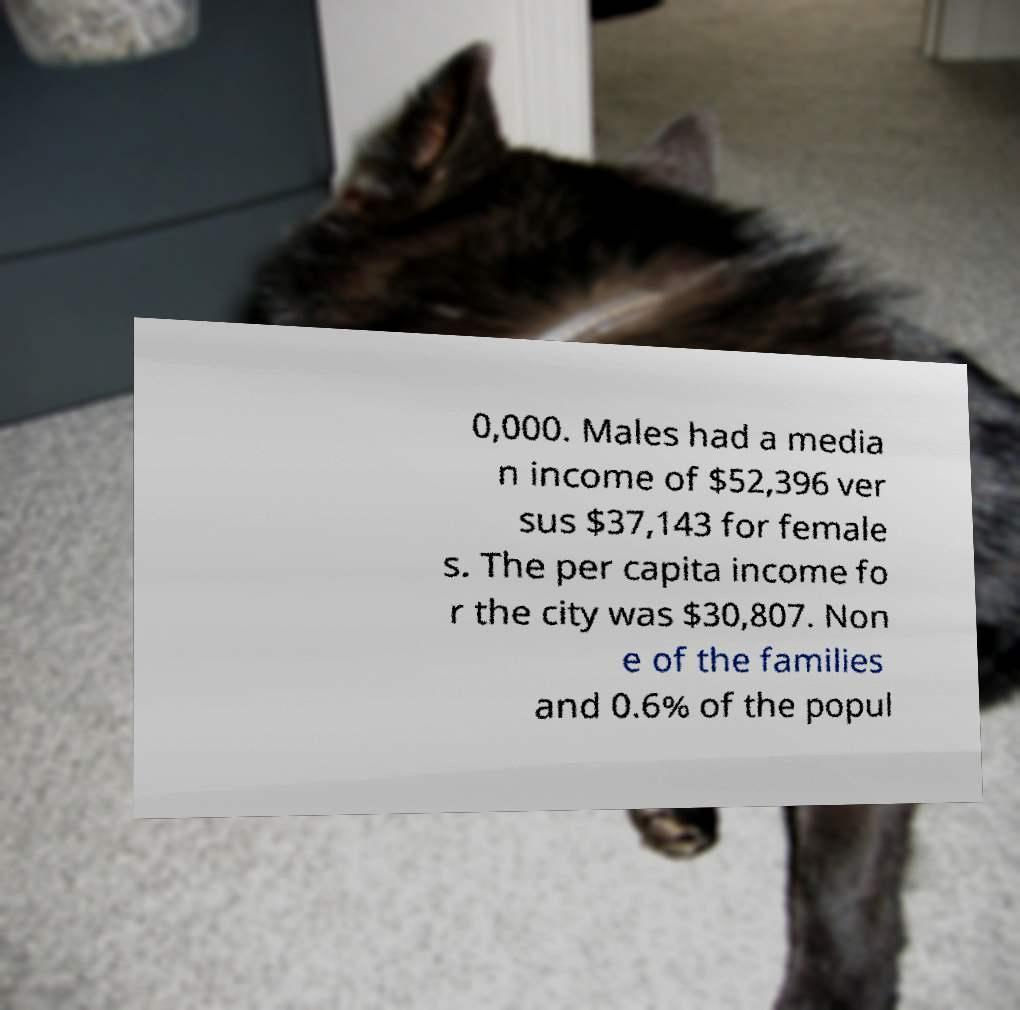Can you accurately transcribe the text from the provided image for me? 0,000. Males had a media n income of $52,396 ver sus $37,143 for female s. The per capita income fo r the city was $30,807. Non e of the families and 0.6% of the popul 